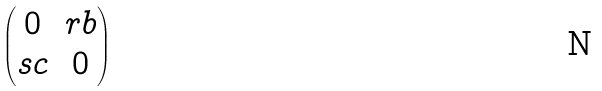<formula> <loc_0><loc_0><loc_500><loc_500>\begin{pmatrix} 0 & r b \\ s c & 0 \end{pmatrix}</formula> 